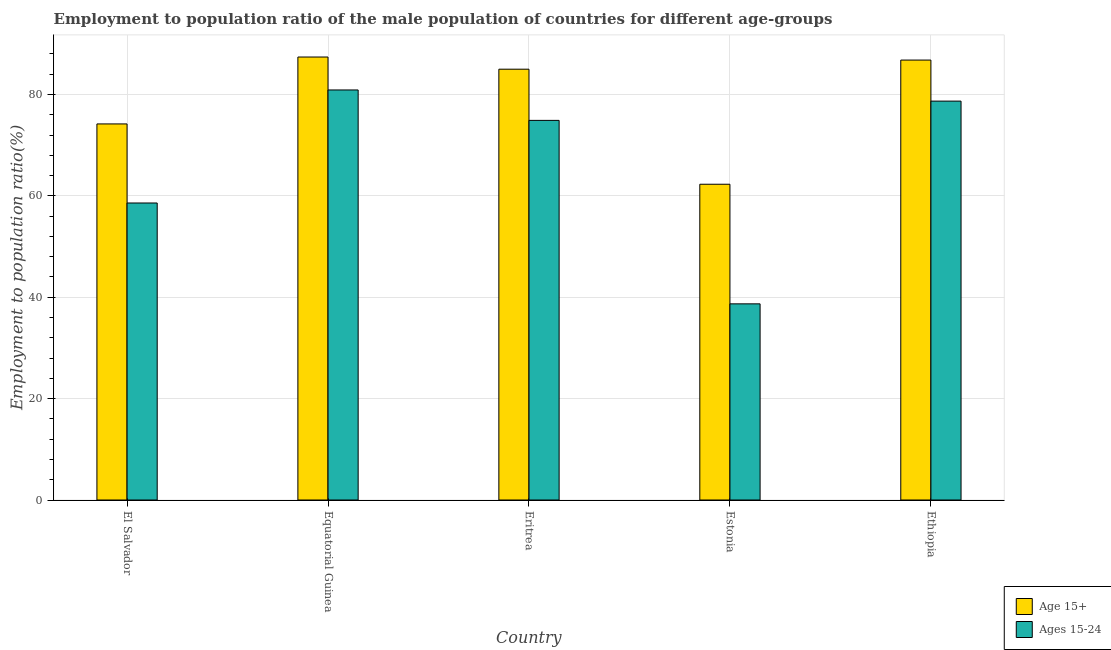Are the number of bars per tick equal to the number of legend labels?
Give a very brief answer. Yes. Are the number of bars on each tick of the X-axis equal?
Keep it short and to the point. Yes. How many bars are there on the 1st tick from the right?
Offer a very short reply. 2. What is the label of the 1st group of bars from the left?
Provide a succinct answer. El Salvador. In how many cases, is the number of bars for a given country not equal to the number of legend labels?
Your answer should be compact. 0. What is the employment to population ratio(age 15+) in Estonia?
Ensure brevity in your answer.  62.3. Across all countries, what is the maximum employment to population ratio(age 15-24)?
Keep it short and to the point. 80.9. Across all countries, what is the minimum employment to population ratio(age 15-24)?
Provide a short and direct response. 38.7. In which country was the employment to population ratio(age 15-24) maximum?
Offer a very short reply. Equatorial Guinea. In which country was the employment to population ratio(age 15-24) minimum?
Your answer should be compact. Estonia. What is the total employment to population ratio(age 15-24) in the graph?
Keep it short and to the point. 331.8. What is the difference between the employment to population ratio(age 15+) in Eritrea and that in Estonia?
Your response must be concise. 22.7. What is the difference between the employment to population ratio(age 15+) in El Salvador and the employment to population ratio(age 15-24) in Eritrea?
Your answer should be very brief. -0.7. What is the average employment to population ratio(age 15-24) per country?
Your answer should be compact. 66.36. What is the difference between the employment to population ratio(age 15+) and employment to population ratio(age 15-24) in Estonia?
Provide a succinct answer. 23.6. What is the ratio of the employment to population ratio(age 15+) in Eritrea to that in Ethiopia?
Your response must be concise. 0.98. Is the employment to population ratio(age 15-24) in El Salvador less than that in Estonia?
Keep it short and to the point. No. Is the difference between the employment to population ratio(age 15+) in Eritrea and Ethiopia greater than the difference between the employment to population ratio(age 15-24) in Eritrea and Ethiopia?
Offer a very short reply. Yes. What is the difference between the highest and the second highest employment to population ratio(age 15-24)?
Provide a short and direct response. 2.2. What is the difference between the highest and the lowest employment to population ratio(age 15+)?
Your answer should be very brief. 25.1. In how many countries, is the employment to population ratio(age 15-24) greater than the average employment to population ratio(age 15-24) taken over all countries?
Provide a succinct answer. 3. Is the sum of the employment to population ratio(age 15+) in El Salvador and Eritrea greater than the maximum employment to population ratio(age 15-24) across all countries?
Your answer should be very brief. Yes. What does the 2nd bar from the left in Equatorial Guinea represents?
Offer a terse response. Ages 15-24. What does the 1st bar from the right in Equatorial Guinea represents?
Offer a terse response. Ages 15-24. What is the difference between two consecutive major ticks on the Y-axis?
Offer a very short reply. 20. Are the values on the major ticks of Y-axis written in scientific E-notation?
Your answer should be very brief. No. Does the graph contain any zero values?
Make the answer very short. No. Does the graph contain grids?
Your answer should be very brief. Yes. Where does the legend appear in the graph?
Offer a terse response. Bottom right. How many legend labels are there?
Offer a terse response. 2. How are the legend labels stacked?
Keep it short and to the point. Vertical. What is the title of the graph?
Give a very brief answer. Employment to population ratio of the male population of countries for different age-groups. What is the label or title of the X-axis?
Provide a succinct answer. Country. What is the Employment to population ratio(%) of Age 15+ in El Salvador?
Provide a succinct answer. 74.2. What is the Employment to population ratio(%) of Ages 15-24 in El Salvador?
Your answer should be compact. 58.6. What is the Employment to population ratio(%) of Age 15+ in Equatorial Guinea?
Give a very brief answer. 87.4. What is the Employment to population ratio(%) in Ages 15-24 in Equatorial Guinea?
Your answer should be compact. 80.9. What is the Employment to population ratio(%) of Ages 15-24 in Eritrea?
Your answer should be very brief. 74.9. What is the Employment to population ratio(%) in Age 15+ in Estonia?
Offer a very short reply. 62.3. What is the Employment to population ratio(%) of Ages 15-24 in Estonia?
Offer a very short reply. 38.7. What is the Employment to population ratio(%) of Age 15+ in Ethiopia?
Ensure brevity in your answer.  86.8. What is the Employment to population ratio(%) of Ages 15-24 in Ethiopia?
Offer a terse response. 78.7. Across all countries, what is the maximum Employment to population ratio(%) in Age 15+?
Provide a short and direct response. 87.4. Across all countries, what is the maximum Employment to population ratio(%) in Ages 15-24?
Ensure brevity in your answer.  80.9. Across all countries, what is the minimum Employment to population ratio(%) in Age 15+?
Make the answer very short. 62.3. Across all countries, what is the minimum Employment to population ratio(%) in Ages 15-24?
Your answer should be compact. 38.7. What is the total Employment to population ratio(%) of Age 15+ in the graph?
Keep it short and to the point. 395.7. What is the total Employment to population ratio(%) of Ages 15-24 in the graph?
Provide a succinct answer. 331.8. What is the difference between the Employment to population ratio(%) of Age 15+ in El Salvador and that in Equatorial Guinea?
Provide a succinct answer. -13.2. What is the difference between the Employment to population ratio(%) of Ages 15-24 in El Salvador and that in Equatorial Guinea?
Make the answer very short. -22.3. What is the difference between the Employment to population ratio(%) in Age 15+ in El Salvador and that in Eritrea?
Your answer should be compact. -10.8. What is the difference between the Employment to population ratio(%) in Ages 15-24 in El Salvador and that in Eritrea?
Ensure brevity in your answer.  -16.3. What is the difference between the Employment to population ratio(%) in Age 15+ in El Salvador and that in Estonia?
Offer a terse response. 11.9. What is the difference between the Employment to population ratio(%) in Ages 15-24 in El Salvador and that in Estonia?
Provide a succinct answer. 19.9. What is the difference between the Employment to population ratio(%) of Age 15+ in El Salvador and that in Ethiopia?
Your response must be concise. -12.6. What is the difference between the Employment to population ratio(%) of Ages 15-24 in El Salvador and that in Ethiopia?
Make the answer very short. -20.1. What is the difference between the Employment to population ratio(%) in Ages 15-24 in Equatorial Guinea and that in Eritrea?
Provide a succinct answer. 6. What is the difference between the Employment to population ratio(%) in Age 15+ in Equatorial Guinea and that in Estonia?
Provide a short and direct response. 25.1. What is the difference between the Employment to population ratio(%) of Ages 15-24 in Equatorial Guinea and that in Estonia?
Ensure brevity in your answer.  42.2. What is the difference between the Employment to population ratio(%) in Ages 15-24 in Equatorial Guinea and that in Ethiopia?
Provide a short and direct response. 2.2. What is the difference between the Employment to population ratio(%) of Age 15+ in Eritrea and that in Estonia?
Ensure brevity in your answer.  22.7. What is the difference between the Employment to population ratio(%) of Ages 15-24 in Eritrea and that in Estonia?
Keep it short and to the point. 36.2. What is the difference between the Employment to population ratio(%) of Age 15+ in Eritrea and that in Ethiopia?
Your answer should be very brief. -1.8. What is the difference between the Employment to population ratio(%) of Age 15+ in Estonia and that in Ethiopia?
Offer a very short reply. -24.5. What is the difference between the Employment to population ratio(%) in Ages 15-24 in Estonia and that in Ethiopia?
Your answer should be compact. -40. What is the difference between the Employment to population ratio(%) of Age 15+ in El Salvador and the Employment to population ratio(%) of Ages 15-24 in Eritrea?
Offer a terse response. -0.7. What is the difference between the Employment to population ratio(%) in Age 15+ in El Salvador and the Employment to population ratio(%) in Ages 15-24 in Estonia?
Keep it short and to the point. 35.5. What is the difference between the Employment to population ratio(%) in Age 15+ in El Salvador and the Employment to population ratio(%) in Ages 15-24 in Ethiopia?
Ensure brevity in your answer.  -4.5. What is the difference between the Employment to population ratio(%) in Age 15+ in Equatorial Guinea and the Employment to population ratio(%) in Ages 15-24 in Estonia?
Your response must be concise. 48.7. What is the difference between the Employment to population ratio(%) of Age 15+ in Eritrea and the Employment to population ratio(%) of Ages 15-24 in Estonia?
Offer a terse response. 46.3. What is the difference between the Employment to population ratio(%) of Age 15+ in Estonia and the Employment to population ratio(%) of Ages 15-24 in Ethiopia?
Make the answer very short. -16.4. What is the average Employment to population ratio(%) of Age 15+ per country?
Keep it short and to the point. 79.14. What is the average Employment to population ratio(%) in Ages 15-24 per country?
Make the answer very short. 66.36. What is the difference between the Employment to population ratio(%) of Age 15+ and Employment to population ratio(%) of Ages 15-24 in El Salvador?
Your answer should be very brief. 15.6. What is the difference between the Employment to population ratio(%) in Age 15+ and Employment to population ratio(%) in Ages 15-24 in Equatorial Guinea?
Offer a very short reply. 6.5. What is the difference between the Employment to population ratio(%) in Age 15+ and Employment to population ratio(%) in Ages 15-24 in Eritrea?
Your answer should be compact. 10.1. What is the difference between the Employment to population ratio(%) in Age 15+ and Employment to population ratio(%) in Ages 15-24 in Estonia?
Ensure brevity in your answer.  23.6. What is the difference between the Employment to population ratio(%) in Age 15+ and Employment to population ratio(%) in Ages 15-24 in Ethiopia?
Keep it short and to the point. 8.1. What is the ratio of the Employment to population ratio(%) of Age 15+ in El Salvador to that in Equatorial Guinea?
Provide a succinct answer. 0.85. What is the ratio of the Employment to population ratio(%) in Ages 15-24 in El Salvador to that in Equatorial Guinea?
Provide a succinct answer. 0.72. What is the ratio of the Employment to population ratio(%) in Age 15+ in El Salvador to that in Eritrea?
Give a very brief answer. 0.87. What is the ratio of the Employment to population ratio(%) of Ages 15-24 in El Salvador to that in Eritrea?
Your answer should be compact. 0.78. What is the ratio of the Employment to population ratio(%) in Age 15+ in El Salvador to that in Estonia?
Keep it short and to the point. 1.19. What is the ratio of the Employment to population ratio(%) of Ages 15-24 in El Salvador to that in Estonia?
Offer a terse response. 1.51. What is the ratio of the Employment to population ratio(%) in Age 15+ in El Salvador to that in Ethiopia?
Provide a succinct answer. 0.85. What is the ratio of the Employment to population ratio(%) of Ages 15-24 in El Salvador to that in Ethiopia?
Your answer should be compact. 0.74. What is the ratio of the Employment to population ratio(%) in Age 15+ in Equatorial Guinea to that in Eritrea?
Offer a terse response. 1.03. What is the ratio of the Employment to population ratio(%) in Ages 15-24 in Equatorial Guinea to that in Eritrea?
Provide a short and direct response. 1.08. What is the ratio of the Employment to population ratio(%) of Age 15+ in Equatorial Guinea to that in Estonia?
Offer a terse response. 1.4. What is the ratio of the Employment to population ratio(%) of Ages 15-24 in Equatorial Guinea to that in Estonia?
Offer a very short reply. 2.09. What is the ratio of the Employment to population ratio(%) in Age 15+ in Equatorial Guinea to that in Ethiopia?
Offer a terse response. 1.01. What is the ratio of the Employment to population ratio(%) in Ages 15-24 in Equatorial Guinea to that in Ethiopia?
Provide a short and direct response. 1.03. What is the ratio of the Employment to population ratio(%) in Age 15+ in Eritrea to that in Estonia?
Ensure brevity in your answer.  1.36. What is the ratio of the Employment to population ratio(%) in Ages 15-24 in Eritrea to that in Estonia?
Your answer should be very brief. 1.94. What is the ratio of the Employment to population ratio(%) of Age 15+ in Eritrea to that in Ethiopia?
Offer a terse response. 0.98. What is the ratio of the Employment to population ratio(%) in Ages 15-24 in Eritrea to that in Ethiopia?
Make the answer very short. 0.95. What is the ratio of the Employment to population ratio(%) of Age 15+ in Estonia to that in Ethiopia?
Offer a terse response. 0.72. What is the ratio of the Employment to population ratio(%) of Ages 15-24 in Estonia to that in Ethiopia?
Give a very brief answer. 0.49. What is the difference between the highest and the second highest Employment to population ratio(%) of Ages 15-24?
Provide a short and direct response. 2.2. What is the difference between the highest and the lowest Employment to population ratio(%) of Age 15+?
Your answer should be very brief. 25.1. What is the difference between the highest and the lowest Employment to population ratio(%) of Ages 15-24?
Ensure brevity in your answer.  42.2. 